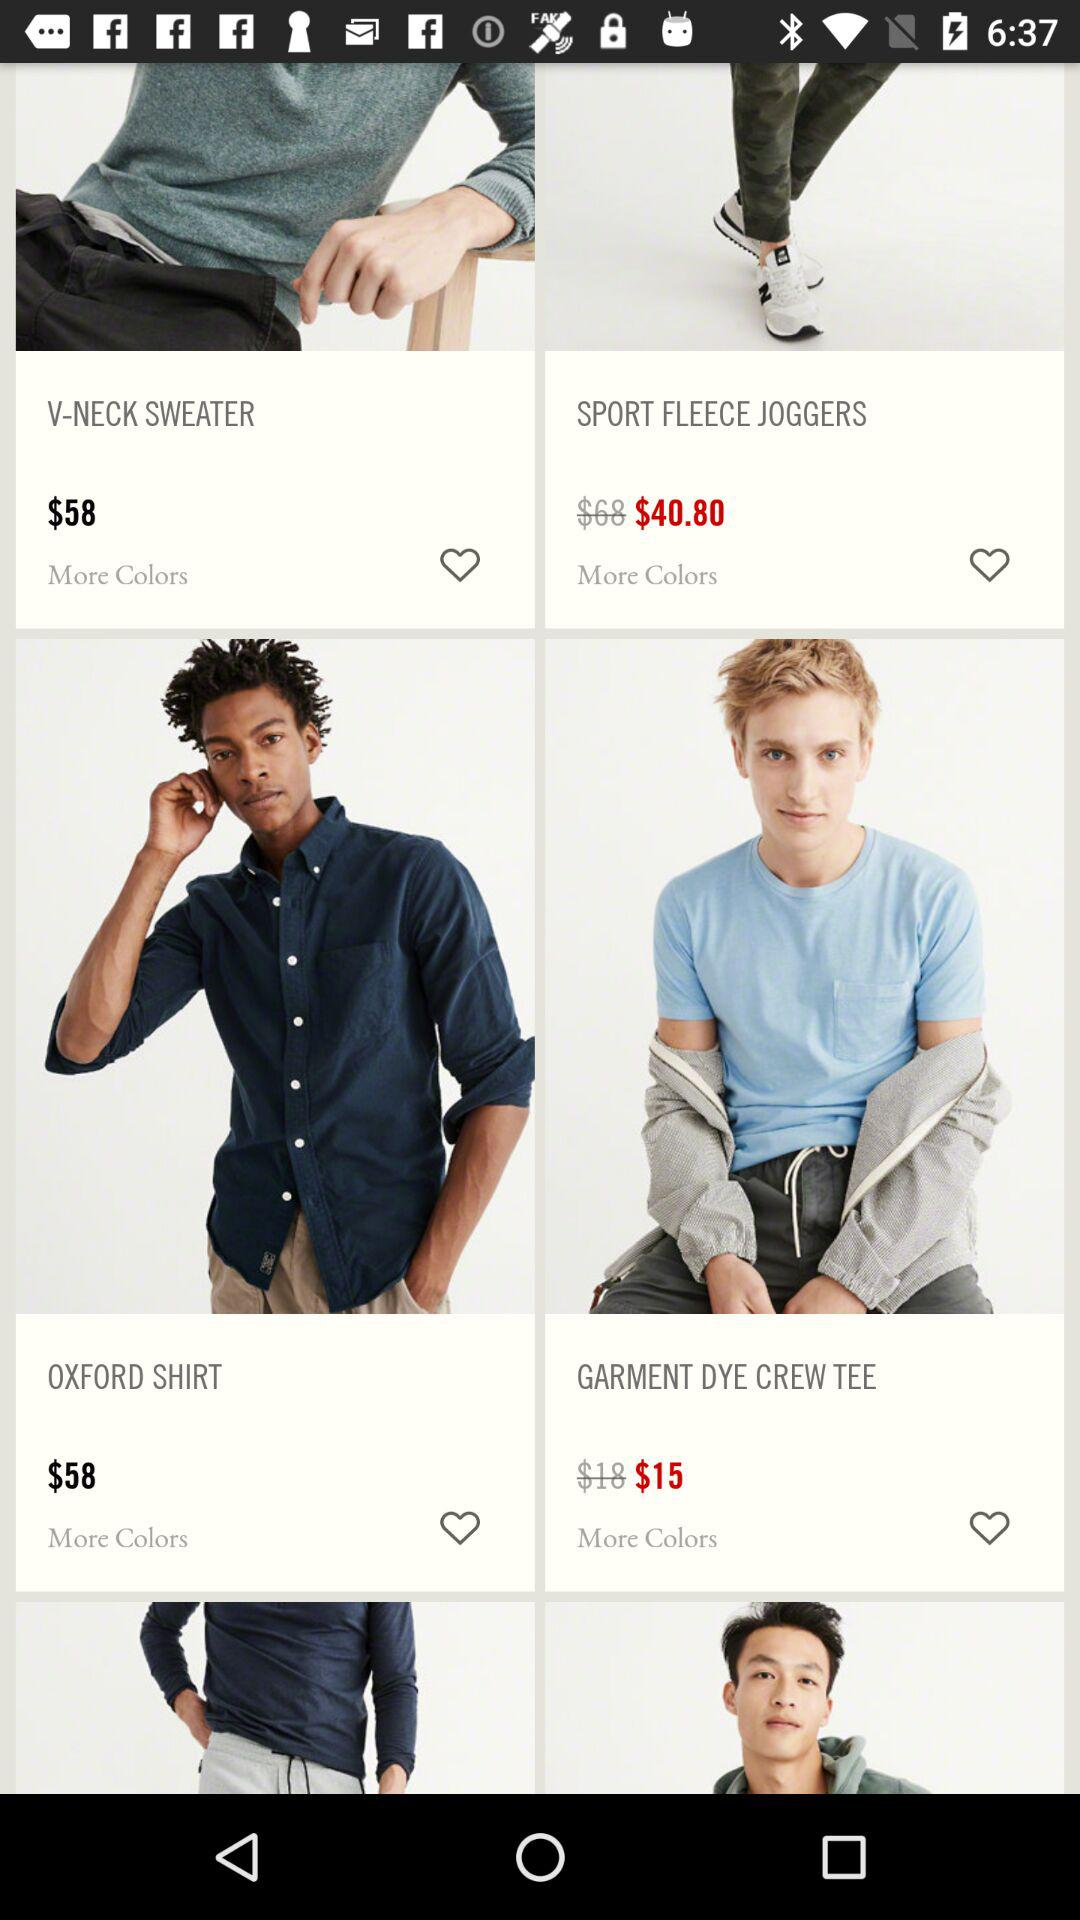How many items have a price of $58?
Answer the question using a single word or phrase. 2 